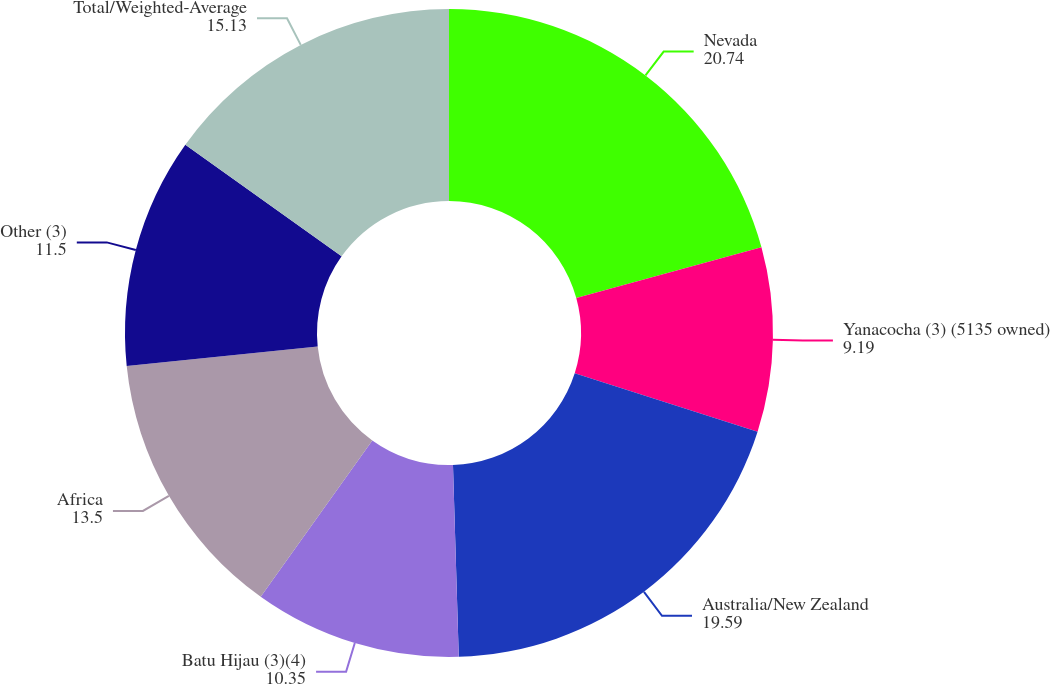Convert chart to OTSL. <chart><loc_0><loc_0><loc_500><loc_500><pie_chart><fcel>Nevada<fcel>Yanacocha (3) (5135 owned)<fcel>Australia/New Zealand<fcel>Batu Hijau (3)(4)<fcel>Africa<fcel>Other (3)<fcel>Total/Weighted-Average<nl><fcel>20.74%<fcel>9.19%<fcel>19.59%<fcel>10.35%<fcel>13.5%<fcel>11.5%<fcel>15.13%<nl></chart> 